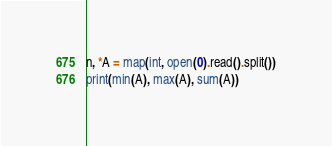Convert code to text. <code><loc_0><loc_0><loc_500><loc_500><_Python_>n, *A = map(int, open(0).read().split())
print(min(A), max(A), sum(A))
</code> 